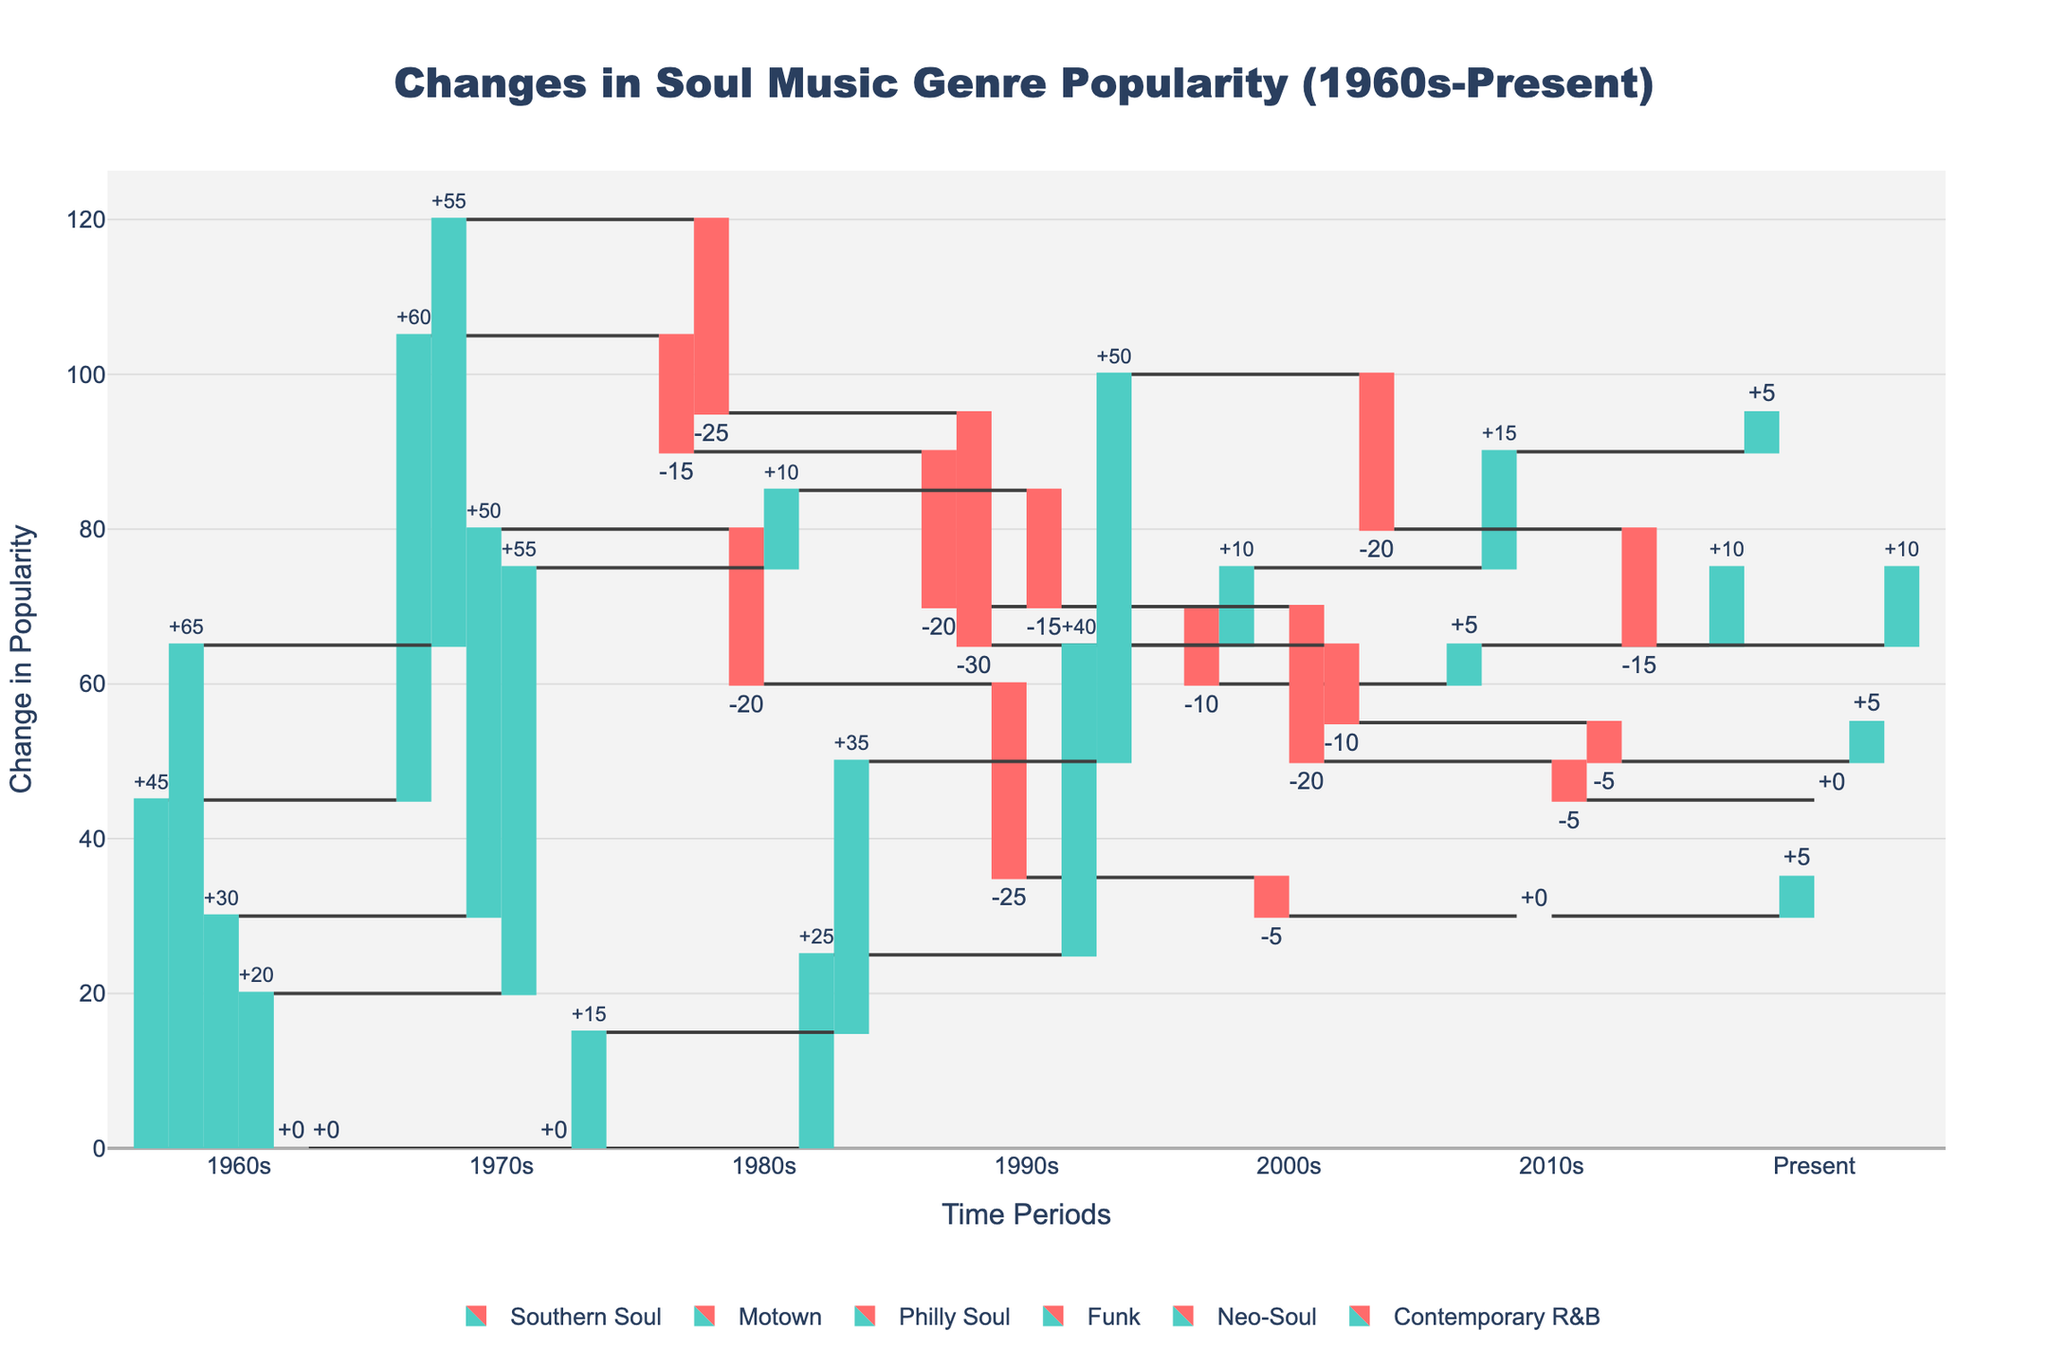What is the title of the chart? The title is the text displayed prominently at the top of the chart. It provides a concise description of what the chart is about. In this case, the title is "Changes in Soul Music Genre Popularity (1960s-Present)."
Answer: Changes in Soul Music Genre Popularity (1960s-Present) How did the popularity of Southern Soul change in the 1980s? The changes in popularity for each genre are represented by the bars corresponding to different time periods. The 1980s bar for Southern Soul shows a decrease by -15.
Answer: -15 Which genre saw the most significant increase in popularity in the 1990s? Comparing the heights of the 1990s bars, Contemporary R&B shows the highest positive value, while other genres either decreased or increased less significantly. The bar for Contemporary R&B in the 1990s shows an increase of +50.
Answer: Contemporary R&B What was the trend in popularity for Funk throughout the decades? To understand the trend for Funk, observe the changes in its values across all periods: 1960s (+20), 1970s (+55), 1980s (+10), 1990s (-15), 2000s (-20), 2010s (-5), and Present (0). Funk initially increased in popularity (1960s-1980s), then declined (1990s-Present).
Answer: Increase then Decrease Compare the change in popularity of Motown and Southern Soul in the 2000s. Which one had a greater increase? Looking at the bars for Motown and Southern Soul in the 2000s, both show increased popularity values: Motown (+10) and Southern Soul (-10) (indicating a decrease). Thus, Motown had a greater increase.
Answer: Motown Which genre maintained consistent popularity without any periods of significant decline? Evaluating each genre's bars and their values, Contemporary R&B steadily increased until the 2000s and experienced a decline afterward. No genres showed consistent popularity without significant decline.
Answer: None What are the cumulative changes in popularity for Neo-Soul from the 1980s to the Present? Sum the values for Neo-Soul from the 1980s onward: 1980s (+25), 1990s (+40), 2000s (-10), 2010s (-5), Present (+5). The sum is 25 + 40 - 10 - 5 + 5 = 55.
Answer: 55 Was there any genre that saw a decline in popularity in every decade after the 1970s? Checking each genre's bars from the 1980s onward, none showed a consistent decline across all these periods.
Answer: No What's the total change in popularity for Motown from the 1960s to the Present? Adding up the changes for each period for Motown: 1960s (+65), 1970s (-25), 1980s (-30), 1990s (+10), 2000s (+15), Present (+5). The total is 65 - 25 - 30 + 10 + 15 + 5 = 40.
Answer: 40 